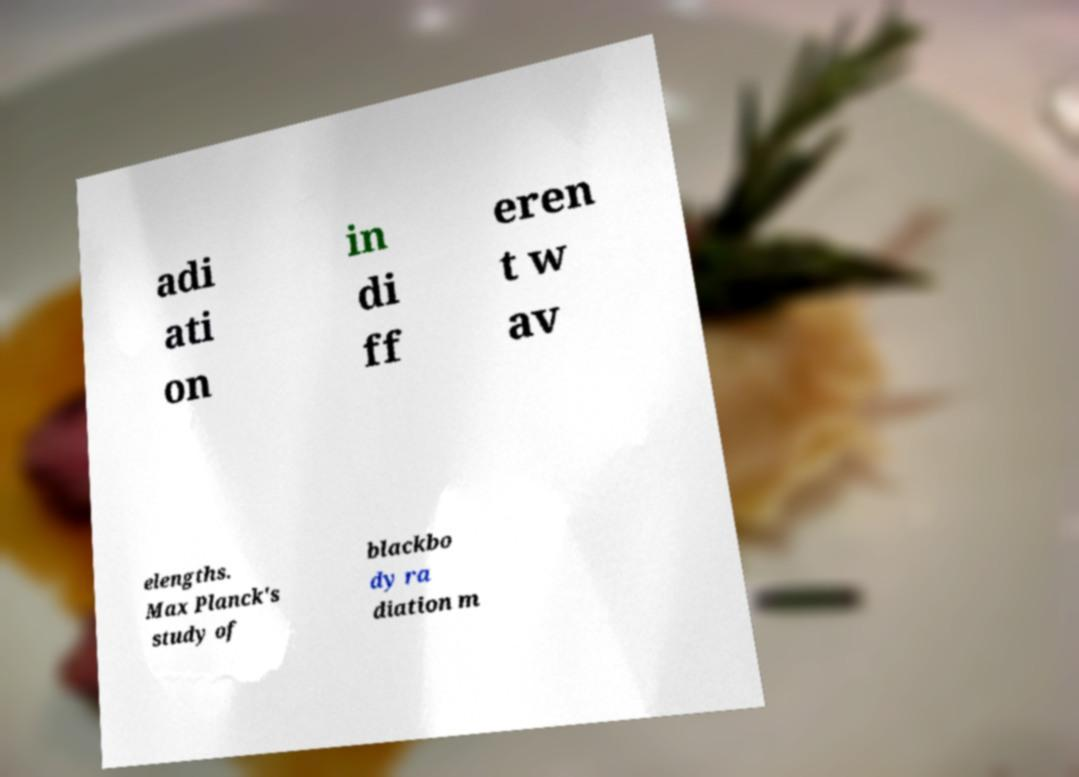Please read and relay the text visible in this image. What does it say? adi ati on in di ff eren t w av elengths. Max Planck's study of blackbo dy ra diation m 